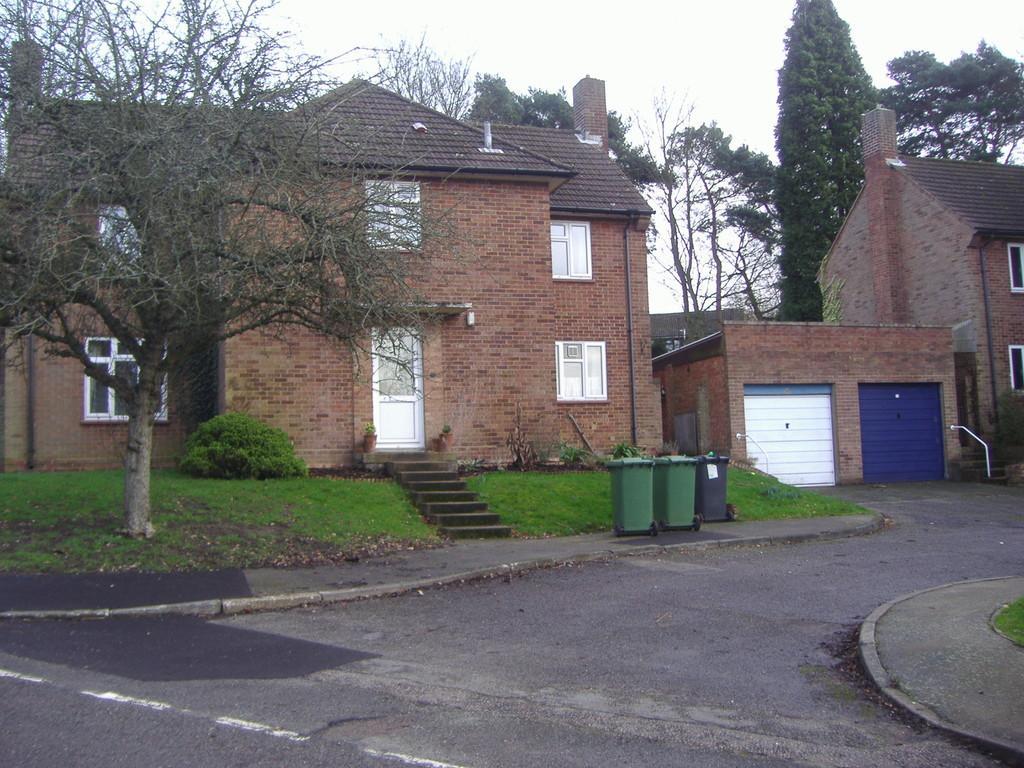Describe this image in one or two sentences. Houses with windows. In-front of this house there are bins, grass, tree and plants. Background there are trees. 